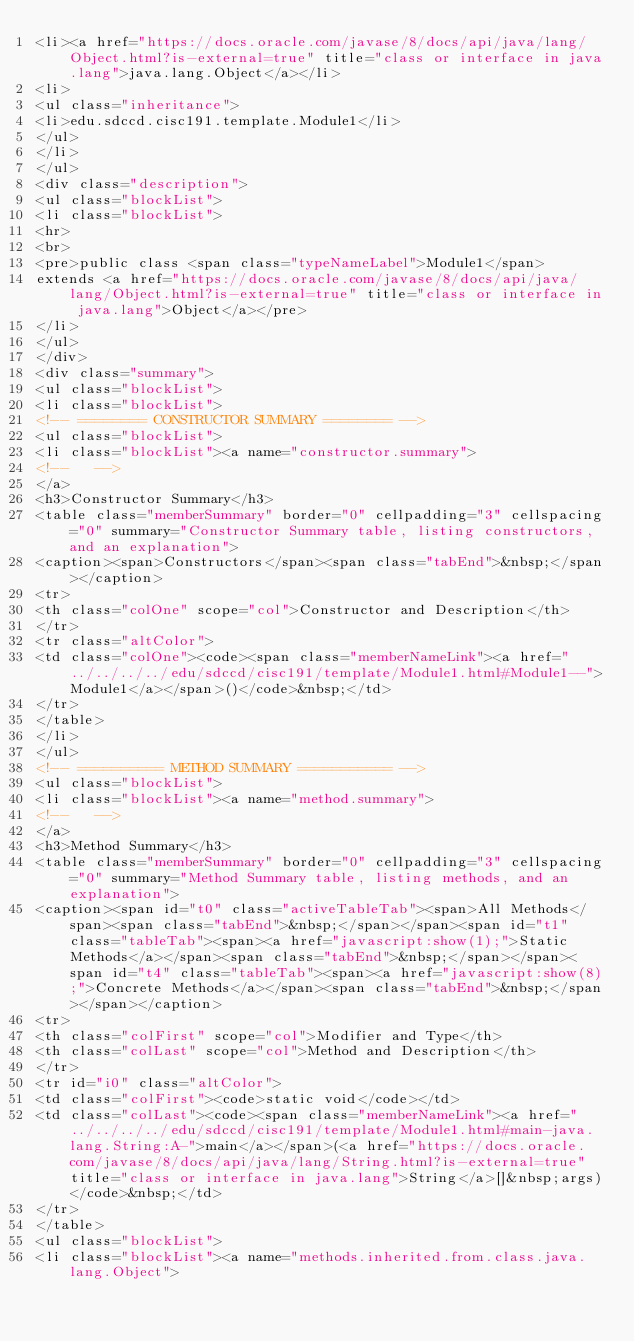Convert code to text. <code><loc_0><loc_0><loc_500><loc_500><_HTML_><li><a href="https://docs.oracle.com/javase/8/docs/api/java/lang/Object.html?is-external=true" title="class or interface in java.lang">java.lang.Object</a></li>
<li>
<ul class="inheritance">
<li>edu.sdccd.cisc191.template.Module1</li>
</ul>
</li>
</ul>
<div class="description">
<ul class="blockList">
<li class="blockList">
<hr>
<br>
<pre>public class <span class="typeNameLabel">Module1</span>
extends <a href="https://docs.oracle.com/javase/8/docs/api/java/lang/Object.html?is-external=true" title="class or interface in java.lang">Object</a></pre>
</li>
</ul>
</div>
<div class="summary">
<ul class="blockList">
<li class="blockList">
<!-- ======== CONSTRUCTOR SUMMARY ======== -->
<ul class="blockList">
<li class="blockList"><a name="constructor.summary">
<!--   -->
</a>
<h3>Constructor Summary</h3>
<table class="memberSummary" border="0" cellpadding="3" cellspacing="0" summary="Constructor Summary table, listing constructors, and an explanation">
<caption><span>Constructors</span><span class="tabEnd">&nbsp;</span></caption>
<tr>
<th class="colOne" scope="col">Constructor and Description</th>
</tr>
<tr class="altColor">
<td class="colOne"><code><span class="memberNameLink"><a href="../../../../edu/sdccd/cisc191/template/Module1.html#Module1--">Module1</a></span>()</code>&nbsp;</td>
</tr>
</table>
</li>
</ul>
<!-- ========== METHOD SUMMARY =========== -->
<ul class="blockList">
<li class="blockList"><a name="method.summary">
<!--   -->
</a>
<h3>Method Summary</h3>
<table class="memberSummary" border="0" cellpadding="3" cellspacing="0" summary="Method Summary table, listing methods, and an explanation">
<caption><span id="t0" class="activeTableTab"><span>All Methods</span><span class="tabEnd">&nbsp;</span></span><span id="t1" class="tableTab"><span><a href="javascript:show(1);">Static Methods</a></span><span class="tabEnd">&nbsp;</span></span><span id="t4" class="tableTab"><span><a href="javascript:show(8);">Concrete Methods</a></span><span class="tabEnd">&nbsp;</span></span></caption>
<tr>
<th class="colFirst" scope="col">Modifier and Type</th>
<th class="colLast" scope="col">Method and Description</th>
</tr>
<tr id="i0" class="altColor">
<td class="colFirst"><code>static void</code></td>
<td class="colLast"><code><span class="memberNameLink"><a href="../../../../edu/sdccd/cisc191/template/Module1.html#main-java.lang.String:A-">main</a></span>(<a href="https://docs.oracle.com/javase/8/docs/api/java/lang/String.html?is-external=true" title="class or interface in java.lang">String</a>[]&nbsp;args)</code>&nbsp;</td>
</tr>
</table>
<ul class="blockList">
<li class="blockList"><a name="methods.inherited.from.class.java.lang.Object"></code> 